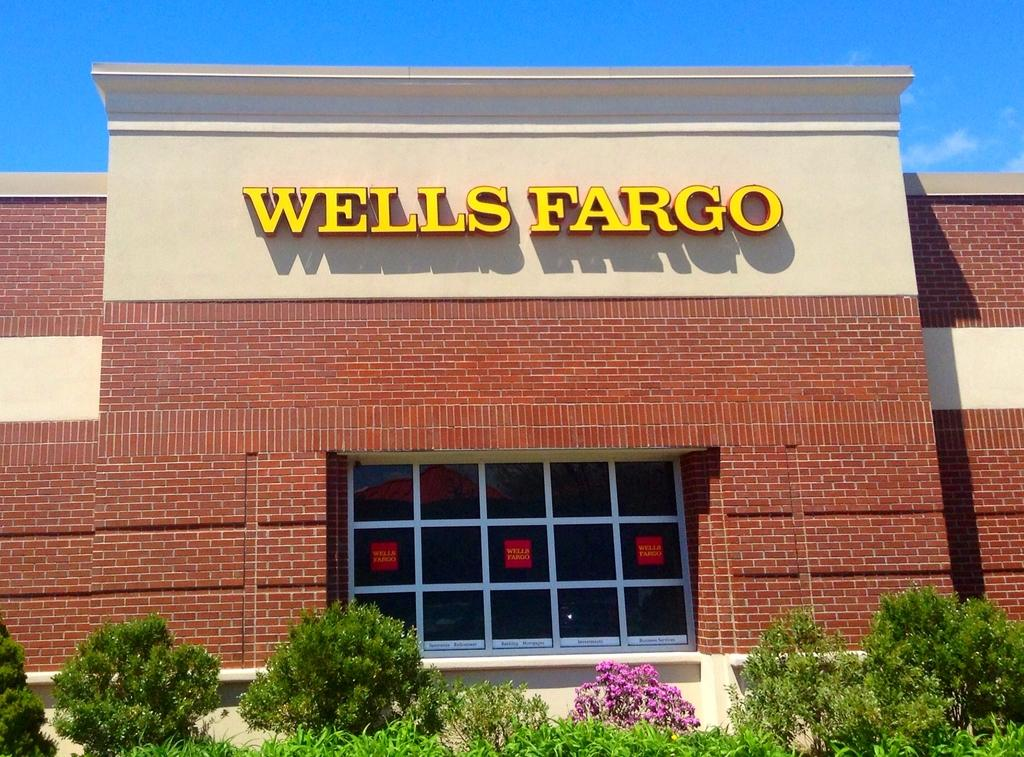What type of structure is in the image? There is a building in the image. What feature can be seen on the building? The building has a glass window. What can be seen in front of the building? There are plants visible in front of the building. What type of punishment is being handed out in front of the building? There is no indication of punishment being handed out in the image; it only shows a building with a glass window and plants in front of it. 